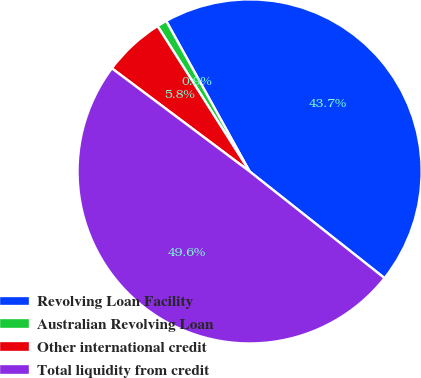Convert chart. <chart><loc_0><loc_0><loc_500><loc_500><pie_chart><fcel>Revolving Loan Facility<fcel>Australian Revolving Loan<fcel>Other international credit<fcel>Total liquidity from credit<nl><fcel>43.7%<fcel>0.93%<fcel>5.79%<fcel>49.58%<nl></chart> 